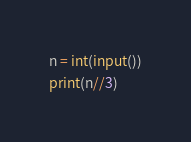<code> <loc_0><loc_0><loc_500><loc_500><_Python_>n = int(input())
print(n//3)
</code> 